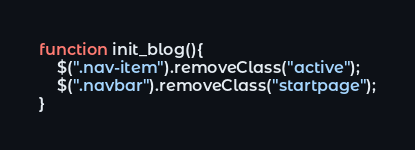Convert code to text. <code><loc_0><loc_0><loc_500><loc_500><_JavaScript_>function init_blog(){
    $(".nav-item").removeClass("active");
    $(".navbar").removeClass("startpage");
}</code> 